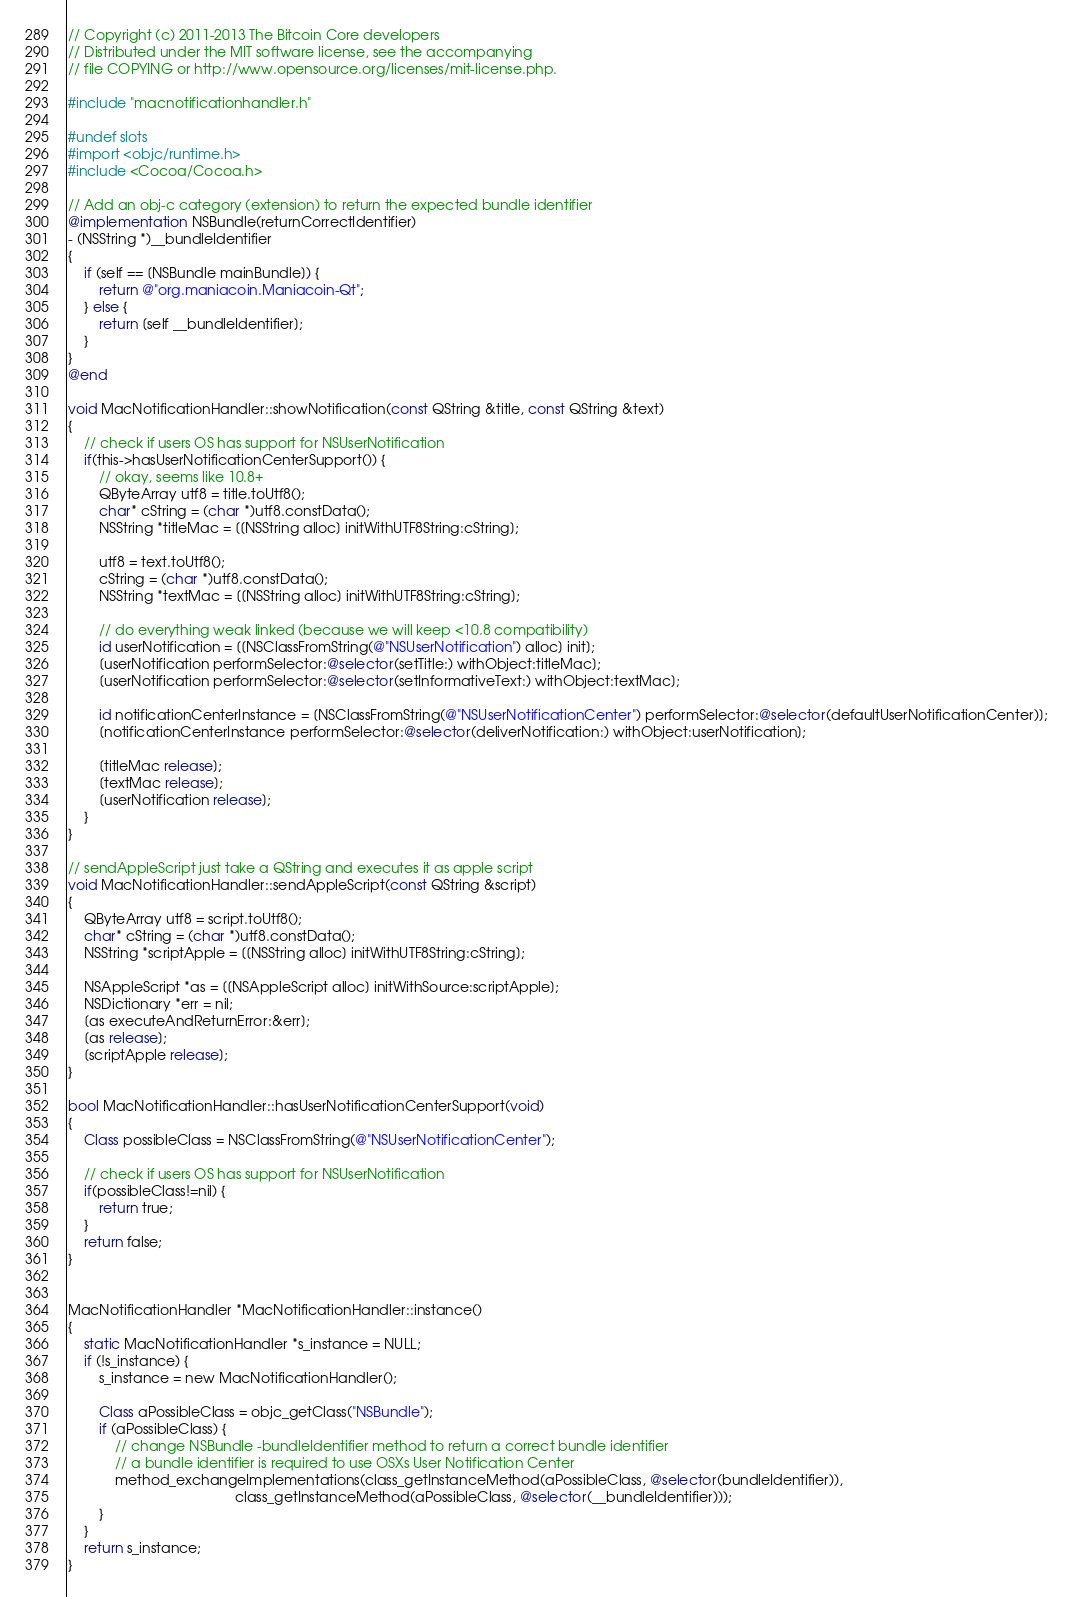<code> <loc_0><loc_0><loc_500><loc_500><_ObjectiveC_>// Copyright (c) 2011-2013 The Bitcoin Core developers
// Distributed under the MIT software license, see the accompanying
// file COPYING or http://www.opensource.org/licenses/mit-license.php.

#include "macnotificationhandler.h"

#undef slots
#import <objc/runtime.h>
#include <Cocoa/Cocoa.h>

// Add an obj-c category (extension) to return the expected bundle identifier
@implementation NSBundle(returnCorrectIdentifier)
- (NSString *)__bundleIdentifier
{
    if (self == [NSBundle mainBundle]) {
        return @"org.maniacoin.Maniacoin-Qt";
    } else {
        return [self __bundleIdentifier];
    }
}
@end

void MacNotificationHandler::showNotification(const QString &title, const QString &text)
{
    // check if users OS has support for NSUserNotification
    if(this->hasUserNotificationCenterSupport()) {
        // okay, seems like 10.8+
        QByteArray utf8 = title.toUtf8();
        char* cString = (char *)utf8.constData();
        NSString *titleMac = [[NSString alloc] initWithUTF8String:cString];

        utf8 = text.toUtf8();
        cString = (char *)utf8.constData();
        NSString *textMac = [[NSString alloc] initWithUTF8String:cString];

        // do everything weak linked (because we will keep <10.8 compatibility)
        id userNotification = [[NSClassFromString(@"NSUserNotification") alloc] init];
        [userNotification performSelector:@selector(setTitle:) withObject:titleMac];
        [userNotification performSelector:@selector(setInformativeText:) withObject:textMac];

        id notificationCenterInstance = [NSClassFromString(@"NSUserNotificationCenter") performSelector:@selector(defaultUserNotificationCenter)];
        [notificationCenterInstance performSelector:@selector(deliverNotification:) withObject:userNotification];

        [titleMac release];
        [textMac release];
        [userNotification release];
    }
}

// sendAppleScript just take a QString and executes it as apple script
void MacNotificationHandler::sendAppleScript(const QString &script)
{
    QByteArray utf8 = script.toUtf8();
    char* cString = (char *)utf8.constData();
    NSString *scriptApple = [[NSString alloc] initWithUTF8String:cString];

    NSAppleScript *as = [[NSAppleScript alloc] initWithSource:scriptApple];
    NSDictionary *err = nil;
    [as executeAndReturnError:&err];
    [as release];
    [scriptApple release];
}

bool MacNotificationHandler::hasUserNotificationCenterSupport(void)
{
    Class possibleClass = NSClassFromString(@"NSUserNotificationCenter");

    // check if users OS has support for NSUserNotification
    if(possibleClass!=nil) {
        return true;
    }
    return false;
}


MacNotificationHandler *MacNotificationHandler::instance()
{
    static MacNotificationHandler *s_instance = NULL;
    if (!s_instance) {
        s_instance = new MacNotificationHandler();
        
        Class aPossibleClass = objc_getClass("NSBundle");
        if (aPossibleClass) {
            // change NSBundle -bundleIdentifier method to return a correct bundle identifier
            // a bundle identifier is required to use OSXs User Notification Center
            method_exchangeImplementations(class_getInstanceMethod(aPossibleClass, @selector(bundleIdentifier)),
                                           class_getInstanceMethod(aPossibleClass, @selector(__bundleIdentifier)));
        }
    }
    return s_instance;
}
</code> 